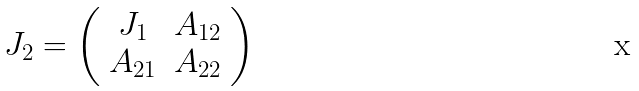Convert formula to latex. <formula><loc_0><loc_0><loc_500><loc_500>J _ { 2 } = \left ( \begin{array} { c c } J _ { 1 } & A _ { 1 2 } \\ A _ { 2 1 } & A _ { 2 2 } \end{array} \right )</formula> 